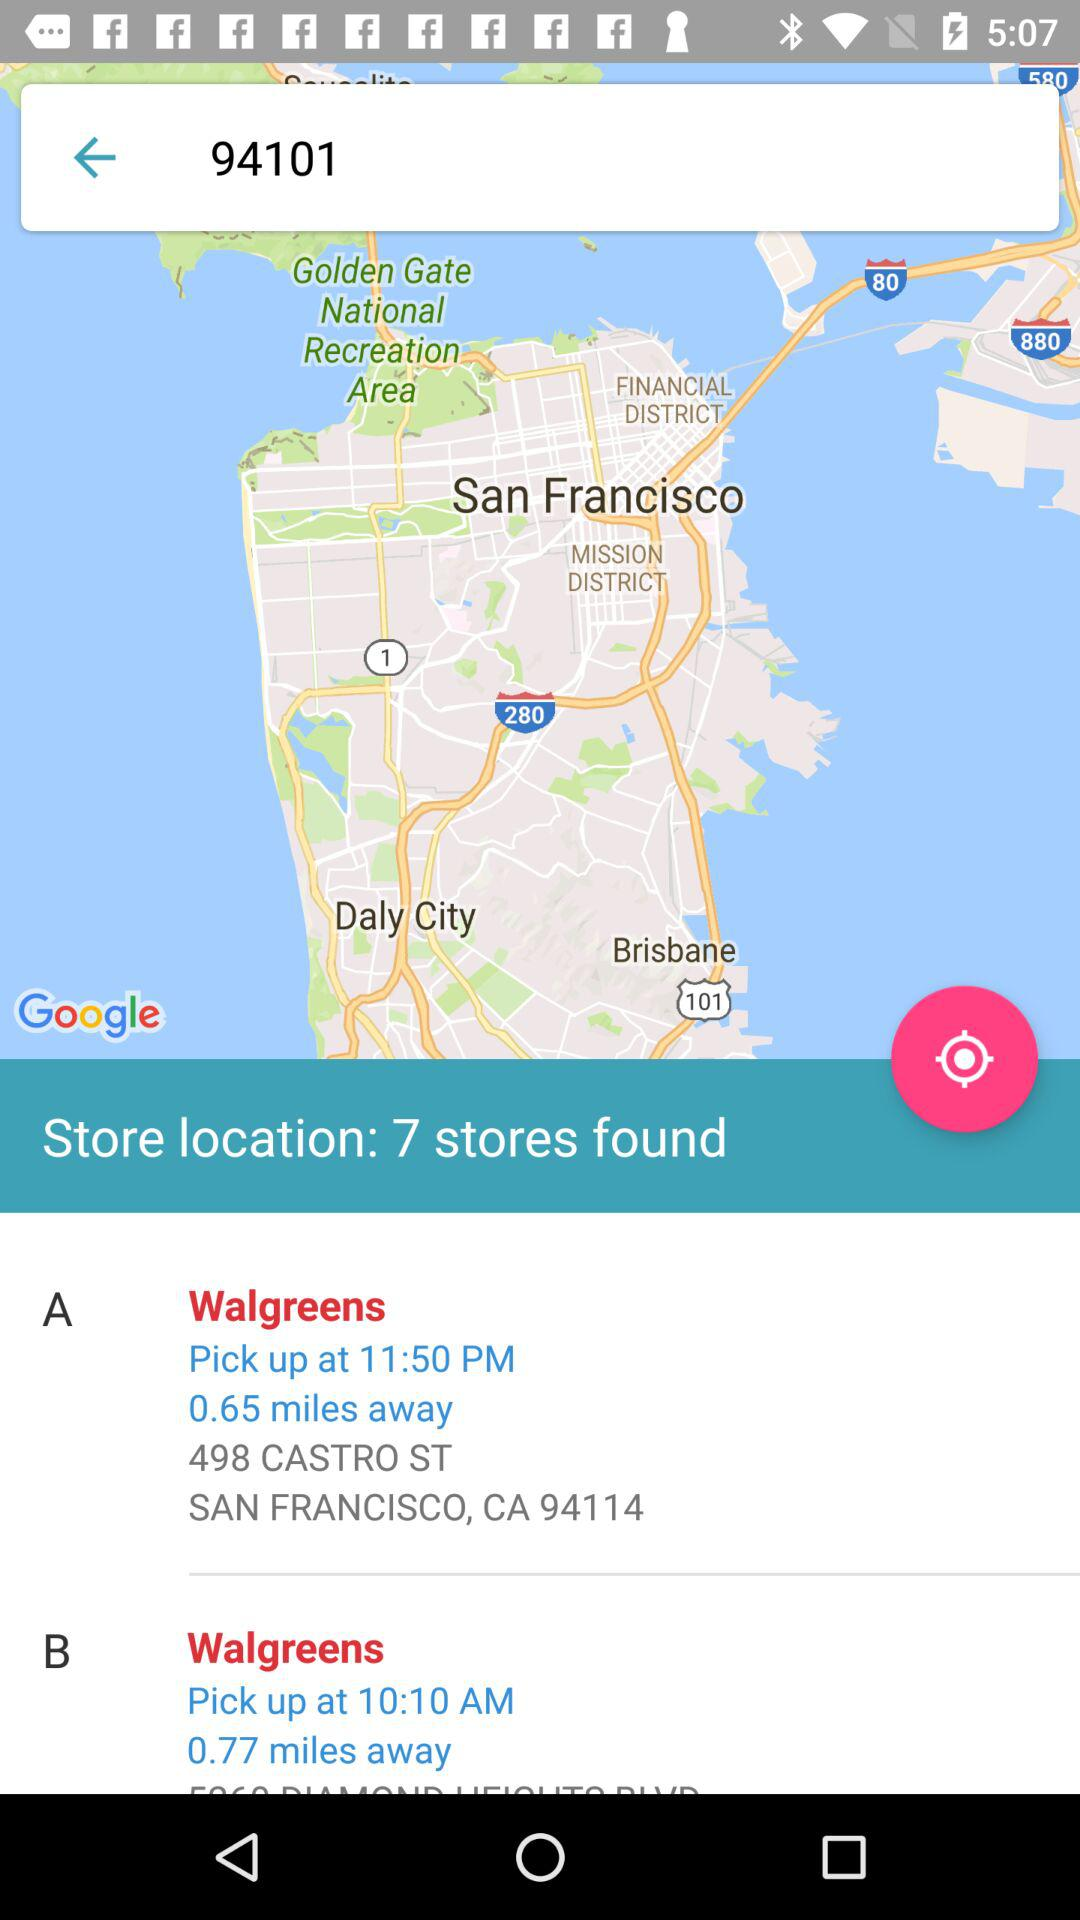What is the zip code for San Francisco, CA? The zip code is 94114. 